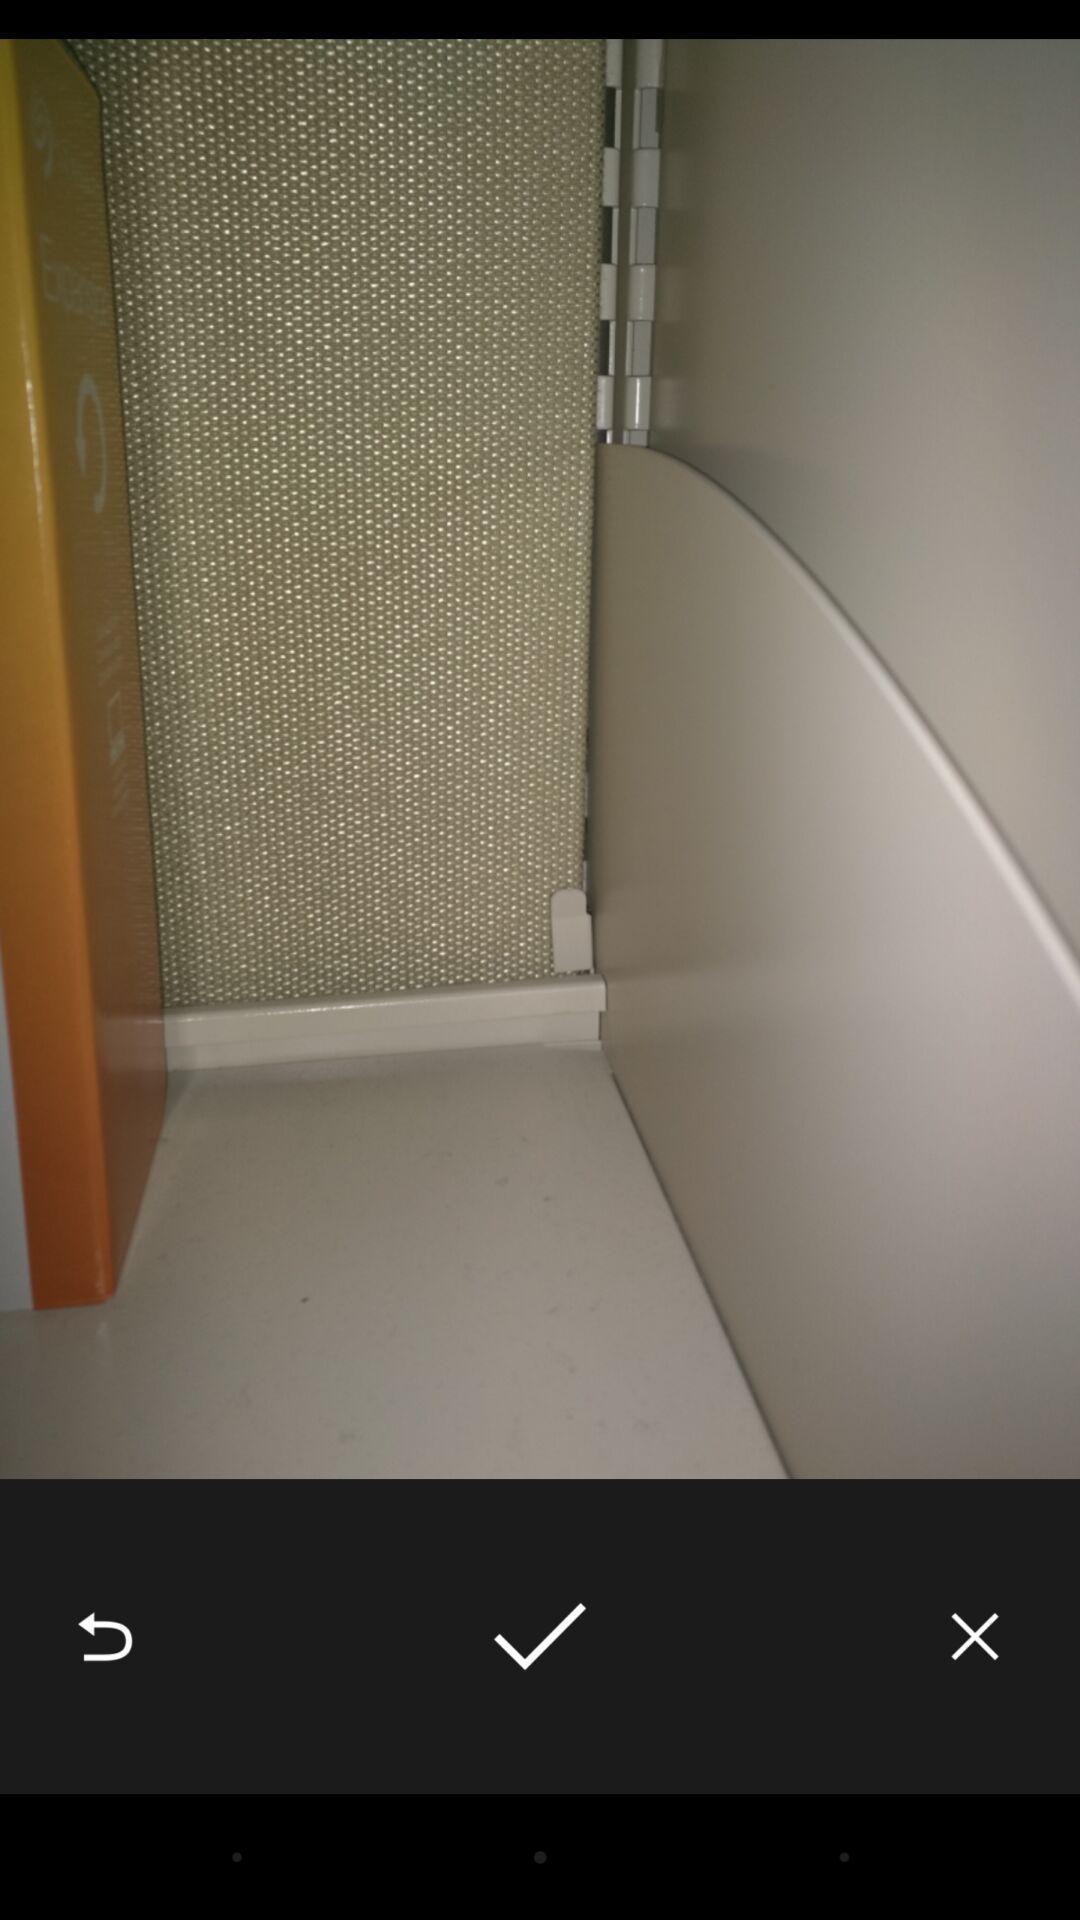Explain the elements present in this screenshot. Picture page of an online location tracking app. 